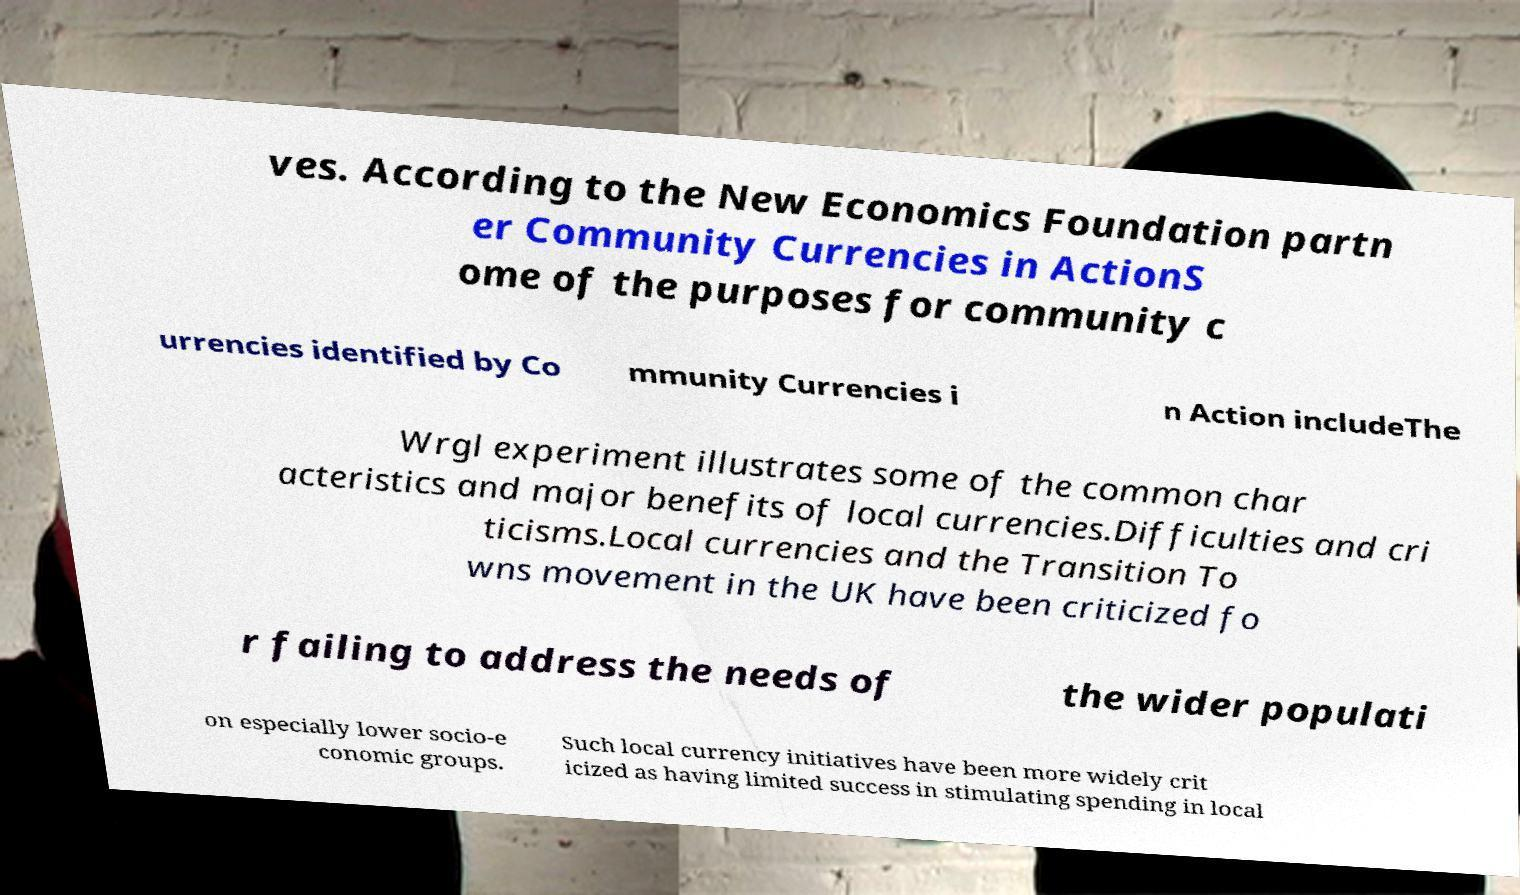There's text embedded in this image that I need extracted. Can you transcribe it verbatim? ves. According to the New Economics Foundation partn er Community Currencies in ActionS ome of the purposes for community c urrencies identified by Co mmunity Currencies i n Action includeThe Wrgl experiment illustrates some of the common char acteristics and major benefits of local currencies.Difficulties and cri ticisms.Local currencies and the Transition To wns movement in the UK have been criticized fo r failing to address the needs of the wider populati on especially lower socio-e conomic groups. Such local currency initiatives have been more widely crit icized as having limited success in stimulating spending in local 